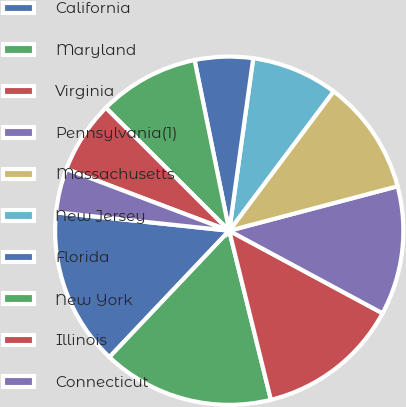Convert chart. <chart><loc_0><loc_0><loc_500><loc_500><pie_chart><fcel>California<fcel>Maryland<fcel>Virginia<fcel>Pennsylvania(1)<fcel>Massachusetts<fcel>New Jersey<fcel>Florida<fcel>New York<fcel>Illinois<fcel>Connecticut<nl><fcel>14.61%<fcel>15.92%<fcel>13.29%<fcel>11.97%<fcel>10.66%<fcel>8.03%<fcel>5.39%<fcel>9.34%<fcel>6.71%<fcel>4.08%<nl></chart> 